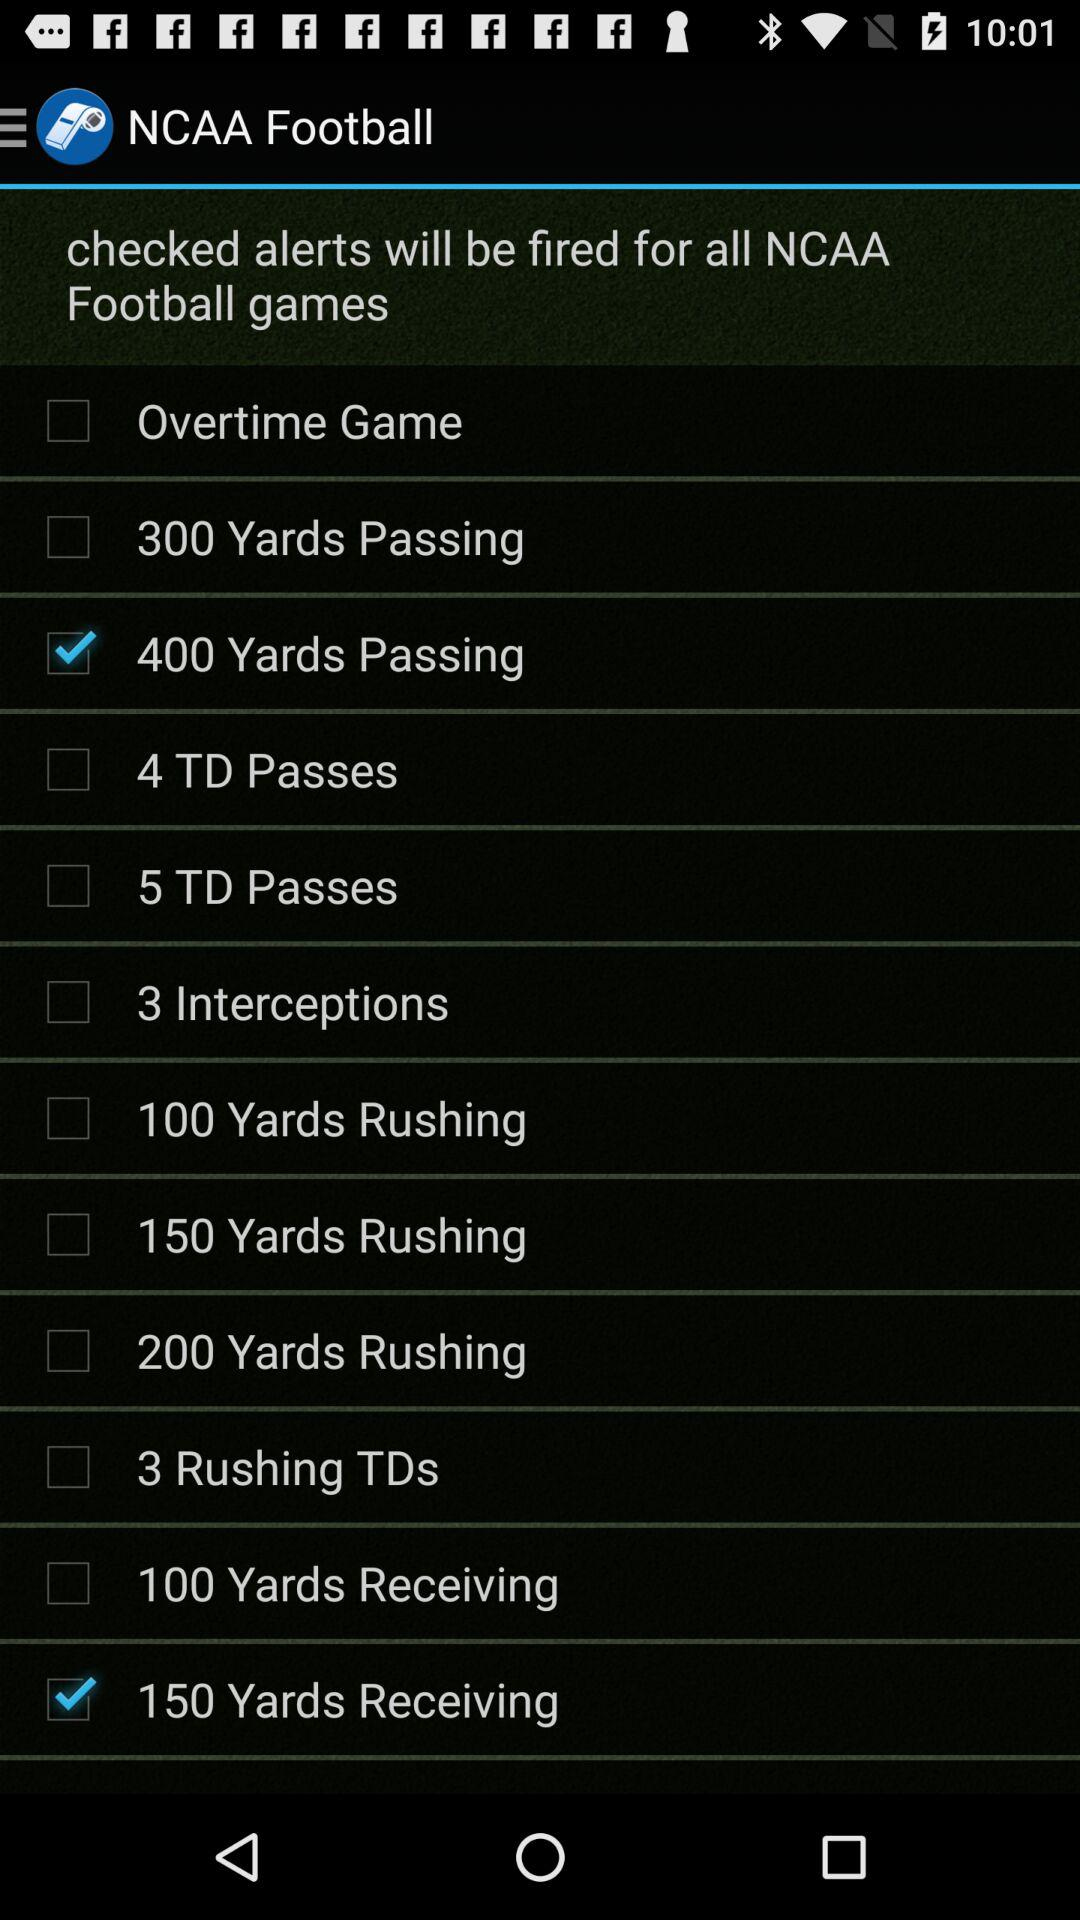What is the current status of "100 Yards Receiving"? The current status is "off". 